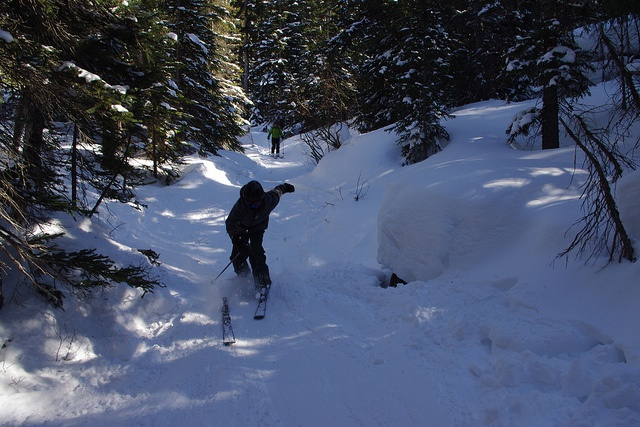Describe the objects in this image and their specific colors. I can see people in black, gray, and navy tones, skis in black, navy, gray, darkblue, and blue tones, and people in black, gray, and darkgreen tones in this image. 